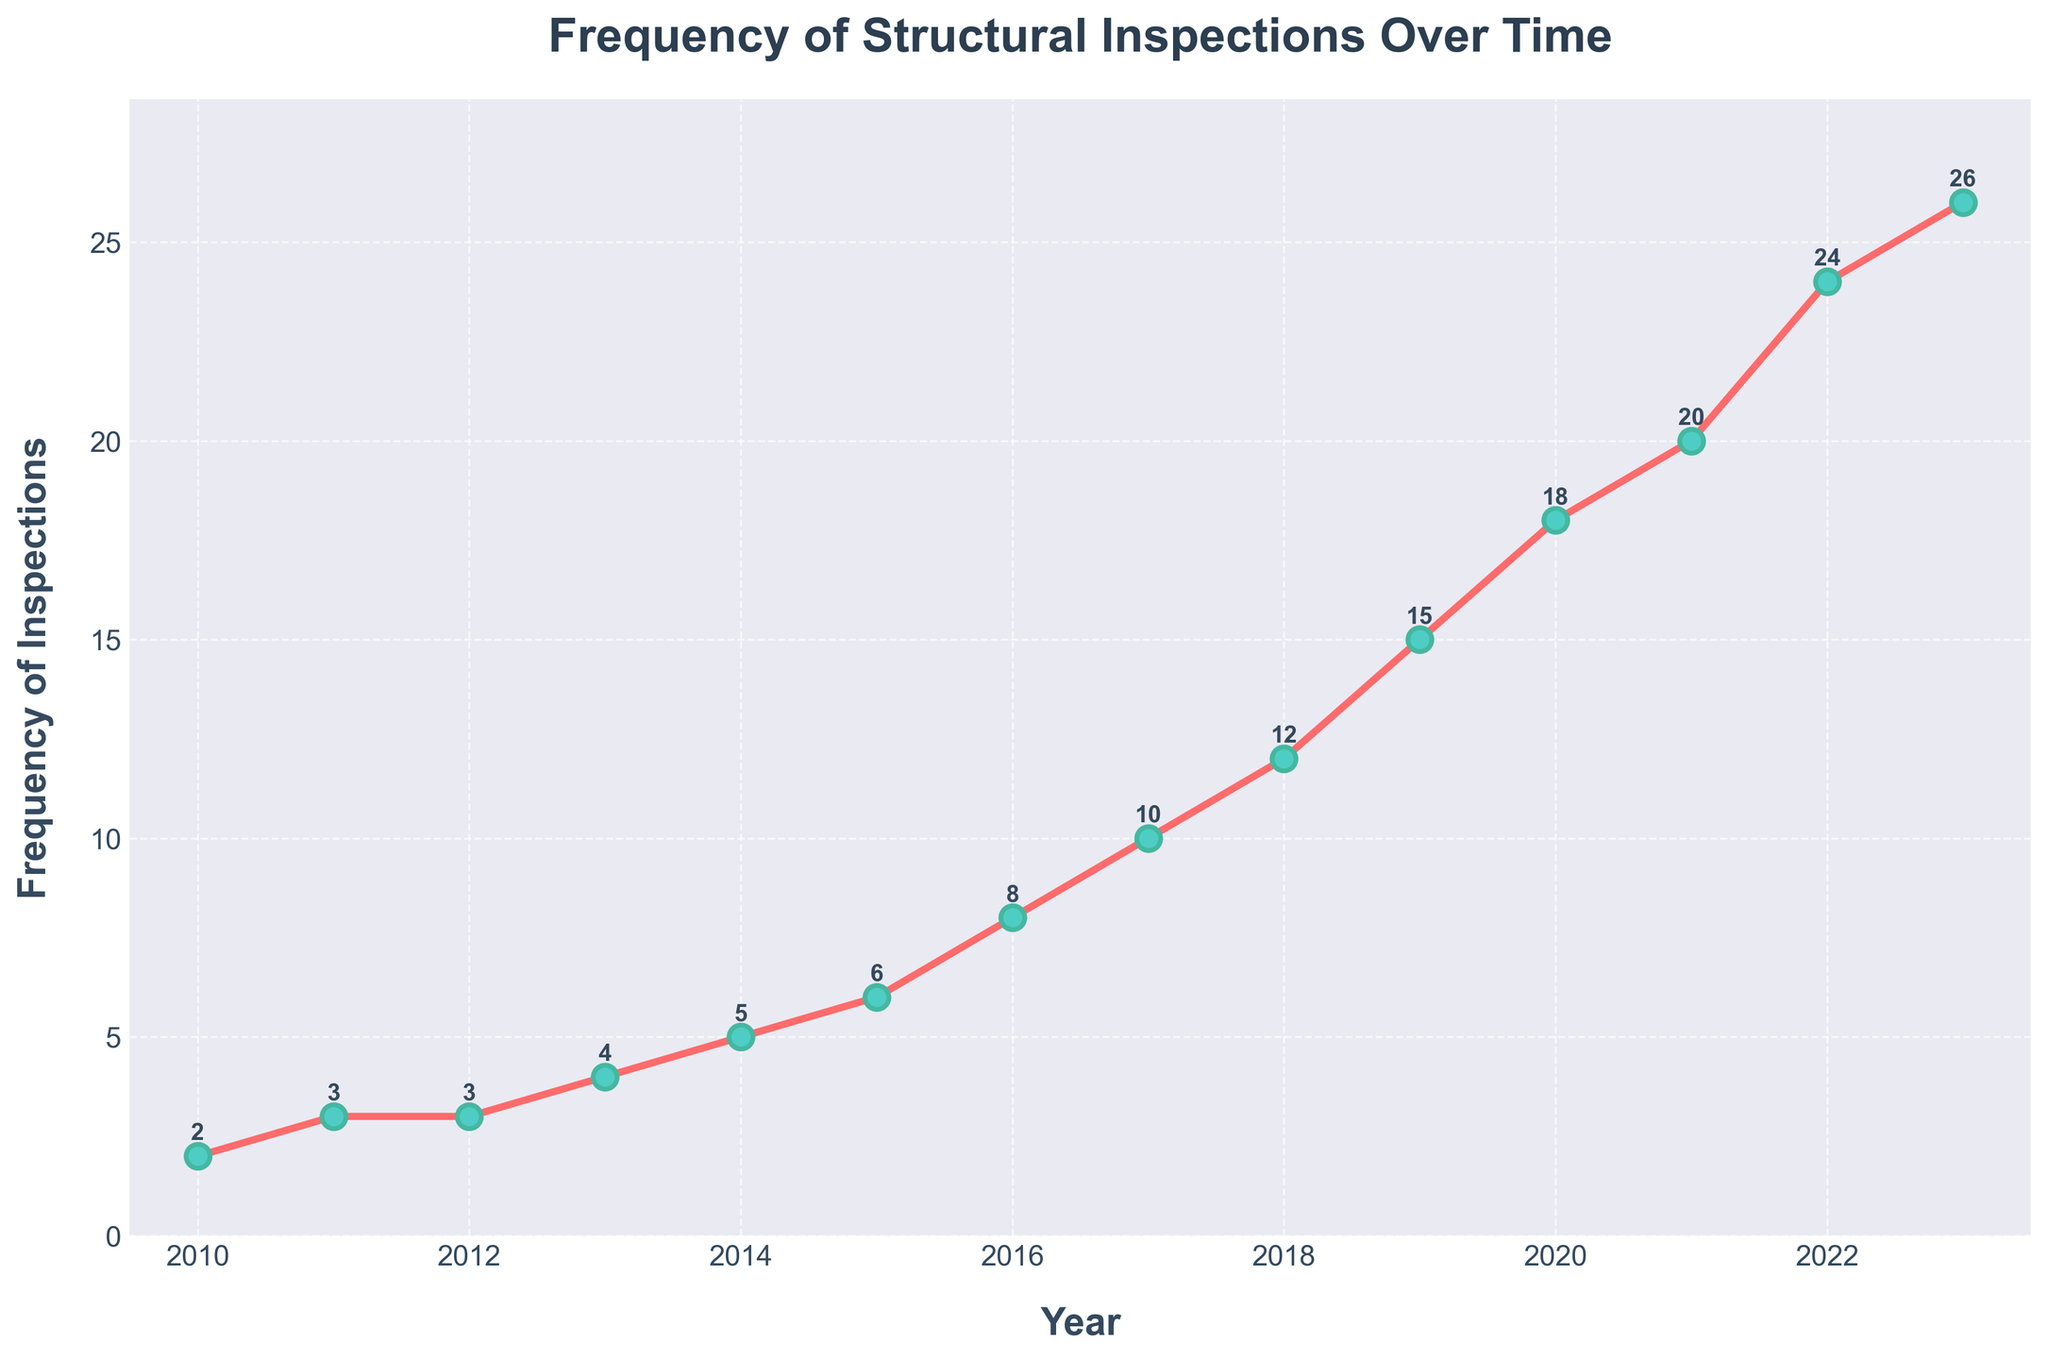What is the frequency of inspections in 2015? Look at the plotted line and find the marker corresponding to the year 2015, then read the value on the y-axis.
Answer: 6 In which year was the frequency of inspections first recorded as double digits? Look at the plotted line and find the first marker where the value exceeds 9 on the y-axis.
Answer: 2017 By how many inspections did the frequency increase from 2010 to 2020? Subtract the frequency of inspections in 2010 from that in 2020. Specifically, 18 (2020) - 2 (2010) = 16.
Answer: 16 How many more inspections were conducted in 2023 compared to 2016? Subtract the frequency of inspections in 2016 from that in 2023. Specifically, 26 (2023) - 8 (2016) = 18.
Answer: 18 What is the average frequency of inspections from 2010 to 2023? Sum the frequencies from 2010 to 2023 (2 + 3 + 3 + 4 + 5 + 6 + 8 + 10 + 12 + 15 + 18 + 20 + 24 + 26) and divide by the number of years (14). Specifically, (2 + 3 + 3 + 4 + 5 + 6 + 8 + 10 + 12 + 15 + 18 + 20 + 24 + 26)/14 ≈ 11.74.
Answer: 11.74 Between which two consecutive years did the frequency of inspections increase the most? Calculate the difference in frequency for consecutive years and identify the pair with the largest difference. The differences are: (2011-2010 = 1), (2012-2011 = 0), (2013-2012 = 1), (2014-2013 = 1), (2015-2014 = 1), (2016-2015 = 2), (2017-2016 = 2), (2018-2017 = 2), (2019-2018 = 3), (2020-2019 = 3), (2021-2020 = 2), (2022-2021 = 4), (2023-2022 = 2). The largest increase is 4 between 2021 and 2022.
Answer: 2021 and 2022 What is the median frequency of inspections over the years 2010 to 2023? Arrange the frequencies in ascending order (2, 3, 3, 4, 5, 6, 8, 10, 12, 15, 18, 20, 24, 26) and find the middle value. Since there are 14 data points, the median is the average of the 7th and 8th values: (8 + 10)/2 = 9.
Answer: 9 Is the trend of inspection frequency increasing or decreasing over time? Observe the plotted line throughout the period from 2010 to 2023. The line shows a consistent increase in height over time.
Answer: Increasing What was the frequency of inspections in 2019? Locate the marker for the year 2019 on the plotted line and read the value on the y-axis.
Answer: 15 